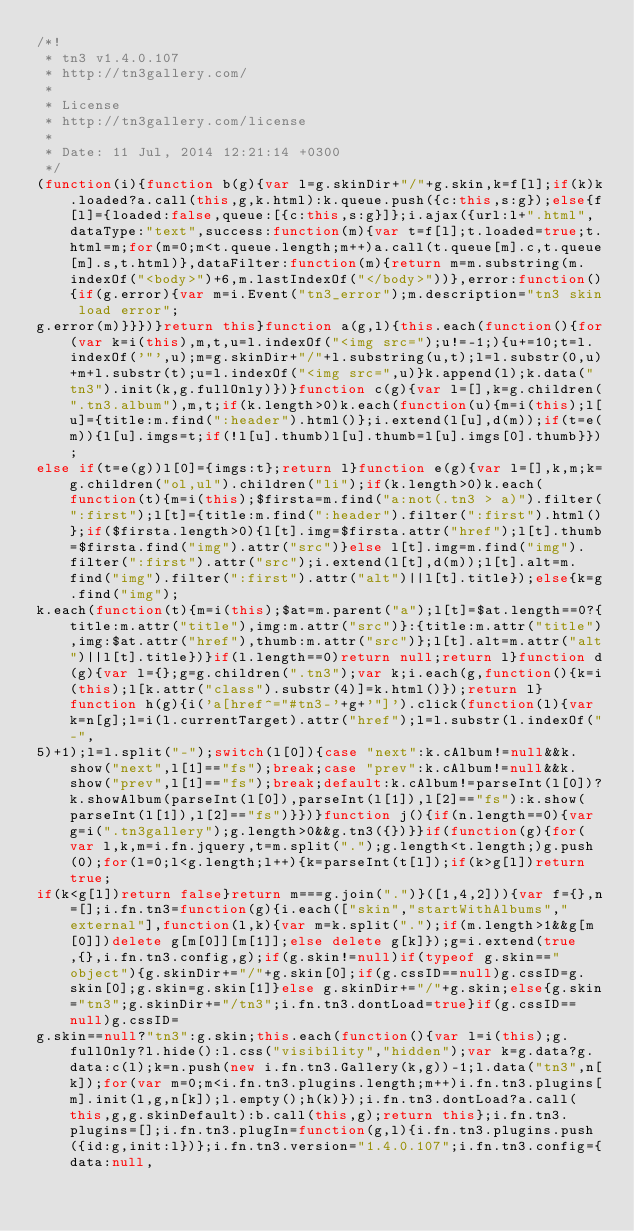<code> <loc_0><loc_0><loc_500><loc_500><_JavaScript_>/*!
 * tn3 v1.4.0.107
 * http://tn3gallery.com/
 *
 * License
 * http://tn3gallery.com/license
 *
 * Date: 11 Jul, 2014 12:21:14 +0300
 */
(function(i){function b(g){var l=g.skinDir+"/"+g.skin,k=f[l];if(k)k.loaded?a.call(this,g,k.html):k.queue.push({c:this,s:g});else{f[l]={loaded:false,queue:[{c:this,s:g}]};i.ajax({url:l+".html",dataType:"text",success:function(m){var t=f[l];t.loaded=true;t.html=m;for(m=0;m<t.queue.length;m++)a.call(t.queue[m].c,t.queue[m].s,t.html)},dataFilter:function(m){return m=m.substring(m.indexOf("<body>")+6,m.lastIndexOf("</body>"))},error:function(){if(g.error){var m=i.Event("tn3_error");m.description="tn3 skin load error";
g.error(m)}}})}return this}function a(g,l){this.each(function(){for(var k=i(this),m,t,u=l.indexOf("<img src=");u!=-1;){u+=10;t=l.indexOf('"',u);m=g.skinDir+"/"+l.substring(u,t);l=l.substr(0,u)+m+l.substr(t);u=l.indexOf("<img src=",u)}k.append(l);k.data("tn3").init(k,g.fullOnly)})}function c(g){var l=[],k=g.children(".tn3.album"),m,t;if(k.length>0)k.each(function(u){m=i(this);l[u]={title:m.find(":header").html()};i.extend(l[u],d(m));if(t=e(m)){l[u].imgs=t;if(!l[u].thumb)l[u].thumb=l[u].imgs[0].thumb}});
else if(t=e(g))l[0]={imgs:t};return l}function e(g){var l=[],k,m;k=g.children("ol,ul").children("li");if(k.length>0)k.each(function(t){m=i(this);$firsta=m.find("a:not(.tn3 > a)").filter(":first");l[t]={title:m.find(":header").filter(":first").html()};if($firsta.length>0){l[t].img=$firsta.attr("href");l[t].thumb=$firsta.find("img").attr("src")}else l[t].img=m.find("img").filter(":first").attr("src");i.extend(l[t],d(m));l[t].alt=m.find("img").filter(":first").attr("alt")||l[t].title});else{k=g.find("img");
k.each(function(t){m=i(this);$at=m.parent("a");l[t]=$at.length==0?{title:m.attr("title"),img:m.attr("src")}:{title:m.attr("title"),img:$at.attr("href"),thumb:m.attr("src")};l[t].alt=m.attr("alt")||l[t].title})}if(l.length==0)return null;return l}function d(g){var l={};g=g.children(".tn3");var k;i.each(g,function(){k=i(this);l[k.attr("class").substr(4)]=k.html()});return l}function h(g){i('a[href^="#tn3-'+g+'"]').click(function(l){var k=n[g];l=i(l.currentTarget).attr("href");l=l.substr(l.indexOf("-",
5)+1);l=l.split("-");switch(l[0]){case "next":k.cAlbum!=null&&k.show("next",l[1]=="fs");break;case "prev":k.cAlbum!=null&&k.show("prev",l[1]=="fs");break;default:k.cAlbum!=parseInt(l[0])?k.showAlbum(parseInt(l[0]),parseInt(l[1]),l[2]=="fs"):k.show(parseInt(l[1]),l[2]=="fs")}})}function j(){if(n.length==0){var g=i(".tn3gallery");g.length>0&&g.tn3({})}}if(function(g){for(var l,k,m=i.fn.jquery,t=m.split(".");g.length<t.length;)g.push(0);for(l=0;l<g.length;l++){k=parseInt(t[l]);if(k>g[l])return true;
if(k<g[l])return false}return m===g.join(".")}([1,4,2])){var f={},n=[];i.fn.tn3=function(g){i.each(["skin","startWithAlbums","external"],function(l,k){var m=k.split(".");if(m.length>1&&g[m[0]])delete g[m[0]][m[1]];else delete g[k]});g=i.extend(true,{},i.fn.tn3.config,g);if(g.skin!=null)if(typeof g.skin=="object"){g.skinDir+="/"+g.skin[0];if(g.cssID==null)g.cssID=g.skin[0];g.skin=g.skin[1]}else g.skinDir+="/"+g.skin;else{g.skin="tn3";g.skinDir+="/tn3";i.fn.tn3.dontLoad=true}if(g.cssID==null)g.cssID=
g.skin==null?"tn3":g.skin;this.each(function(){var l=i(this);g.fullOnly?l.hide():l.css("visibility","hidden");var k=g.data?g.data:c(l);k=n.push(new i.fn.tn3.Gallery(k,g))-1;l.data("tn3",n[k]);for(var m=0;m<i.fn.tn3.plugins.length;m++)i.fn.tn3.plugins[m].init(l,g,n[k]);l.empty();h(k)});i.fn.tn3.dontLoad?a.call(this,g,g.skinDefault):b.call(this,g);return this};i.fn.tn3.plugins=[];i.fn.tn3.plugIn=function(g,l){i.fn.tn3.plugins.push({id:g,init:l})};i.fn.tn3.version="1.4.0.107";i.fn.tn3.config={data:null,</code> 